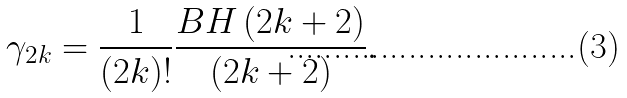Convert formula to latex. <formula><loc_0><loc_0><loc_500><loc_500>\gamma _ { 2 k } = \frac { 1 } { \left ( 2 k \right ) ! } \frac { B H \left ( 2 k + 2 \right ) } { \left ( 2 k + 2 \right ) } .</formula> 